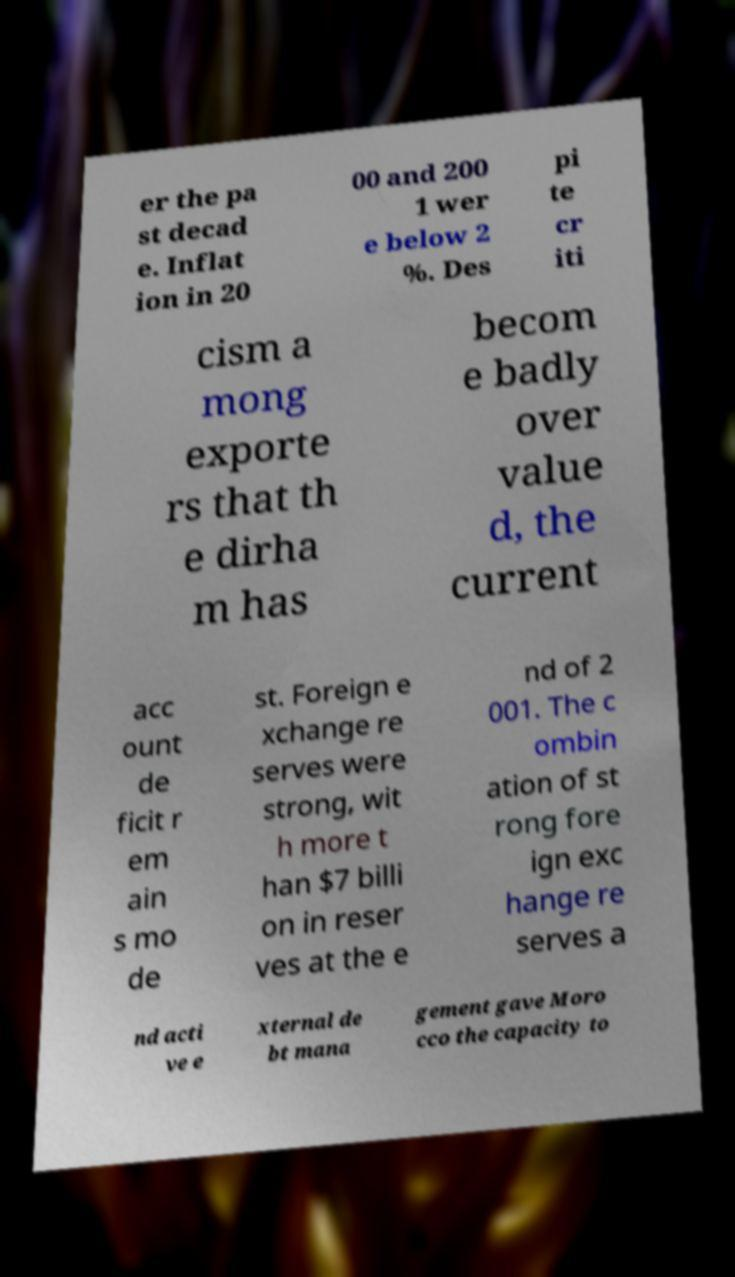There's text embedded in this image that I need extracted. Can you transcribe it verbatim? er the pa st decad e. Inflat ion in 20 00 and 200 1 wer e below 2 %. Des pi te cr iti cism a mong exporte rs that th e dirha m has becom e badly over value d, the current acc ount de ficit r em ain s mo de st. Foreign e xchange re serves were strong, wit h more t han $7 billi on in reser ves at the e nd of 2 001. The c ombin ation of st rong fore ign exc hange re serves a nd acti ve e xternal de bt mana gement gave Moro cco the capacity to 